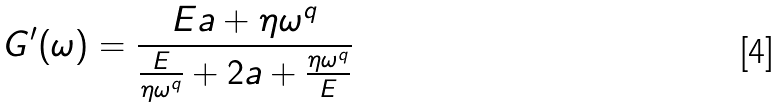<formula> <loc_0><loc_0><loc_500><loc_500>G ^ { \prime } ( \omega ) = \frac { E a + \eta \omega ^ { q } } { \frac { E } { \eta \omega ^ { q } } + 2 a + \frac { \eta \omega ^ { q } } { E } }</formula> 